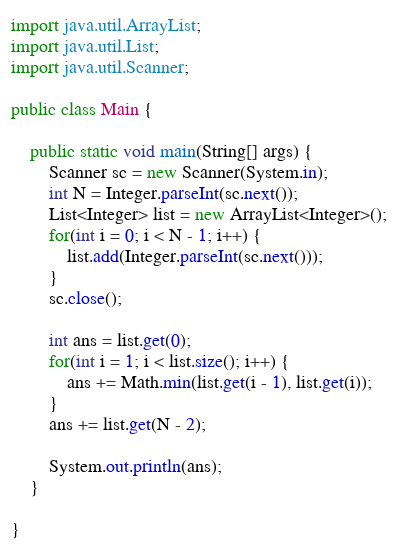Convert code to text. <code><loc_0><loc_0><loc_500><loc_500><_Java_>import java.util.ArrayList;
import java.util.List;
import java.util.Scanner;

public class Main {

	public static void main(String[] args) {
		Scanner sc = new Scanner(System.in);
		int N = Integer.parseInt(sc.next());
		List<Integer> list = new ArrayList<Integer>();
		for(int i = 0; i < N - 1; i++) {
			list.add(Integer.parseInt(sc.next()));
		}
		sc.close();

		int ans = list.get(0);
		for(int i = 1; i < list.size(); i++) {
			ans += Math.min(list.get(i - 1), list.get(i));
		}
		ans += list.get(N - 2);

		System.out.println(ans);
	}

}</code> 